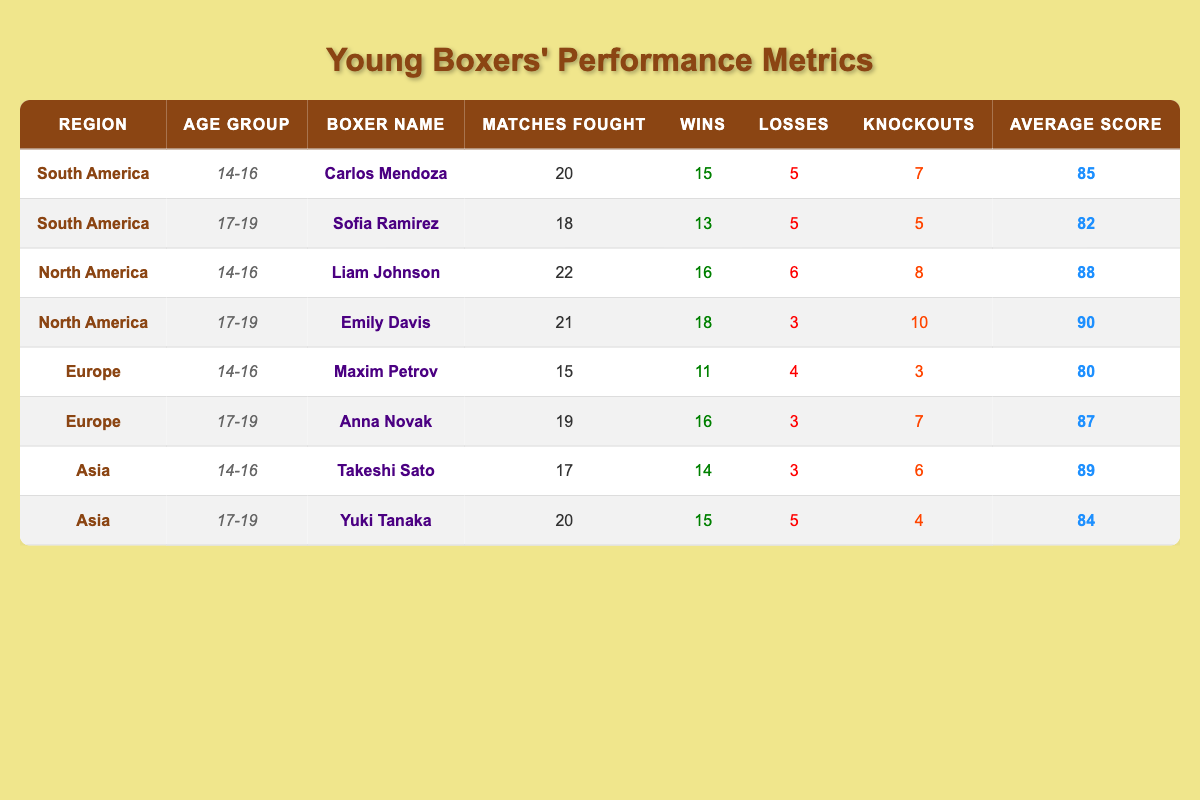What is the win-loss record for Carlos Mendoza? Carlos Mendoza fought 20 matches, winning 15 and losing 5. Therefore, his win-loss record is 15 wins and 5 losses.
Answer: 15 wins, 5 losses Which boxer has the highest average score among the 17-19 age group? In the 17-19 age group, there are two boxers: Sofia Ramirez (average score 82) and Emily Davis (average score 90). Emily Davis has the highest average score of 90.
Answer: Emily Davis, 90 How many total matches were fought by boxers in the North America region? Liam Johnson fought 22 matches and Emily Davis fought 21 matches, totaling 22 + 21 = 43 matches fought by North American boxers.
Answer: 43 Is it true that Takeshi Sato has more wins than losses? Takeshi Sato won 14 matches and lost 3 matches. Since 14 is greater than 3, the statement is true.
Answer: Yes What is the average number of knockouts for boxers in the 14-16 age group? For the 14-16 age group, the boxers are Carlos Mendoza (7 knockouts), Liam Johnson (8 knockouts), Maxim Petrov (3 knockouts), and Takeshi Sato (6 knockouts). The total knockouts are 7 + 8 + 3 + 6 = 24, and there are 4 boxers. Thus, the average is 24/4 = 6.
Answer: 6 